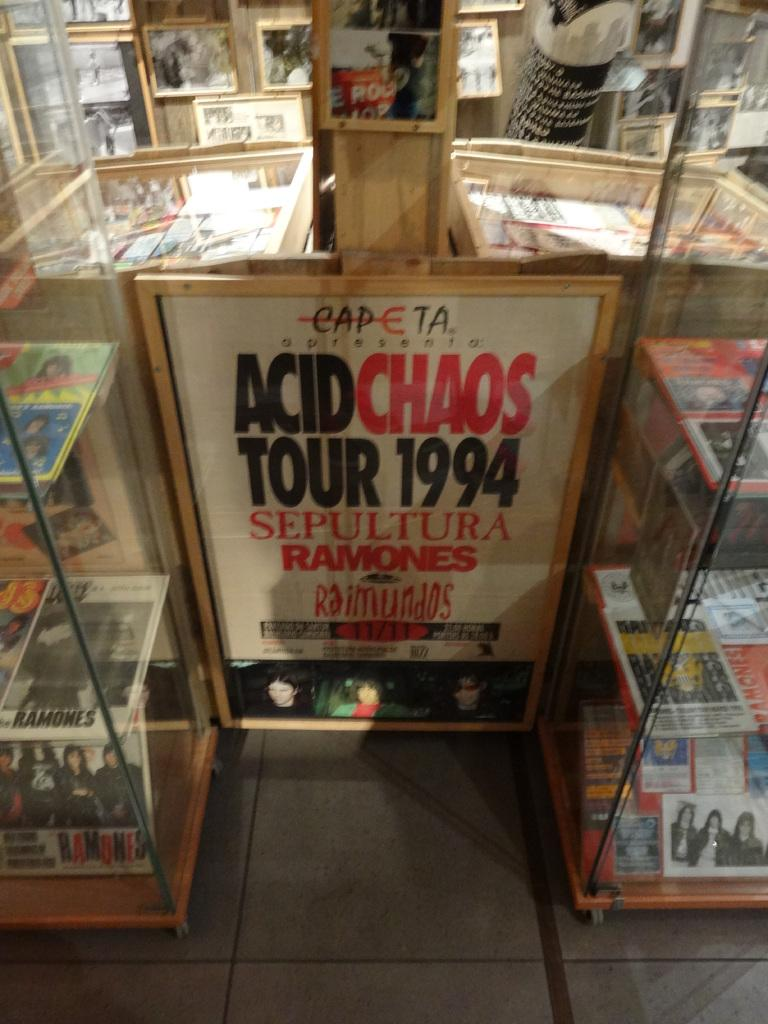<image>
Provide a brief description of the given image. A sign has the year 1994 on it in black. 